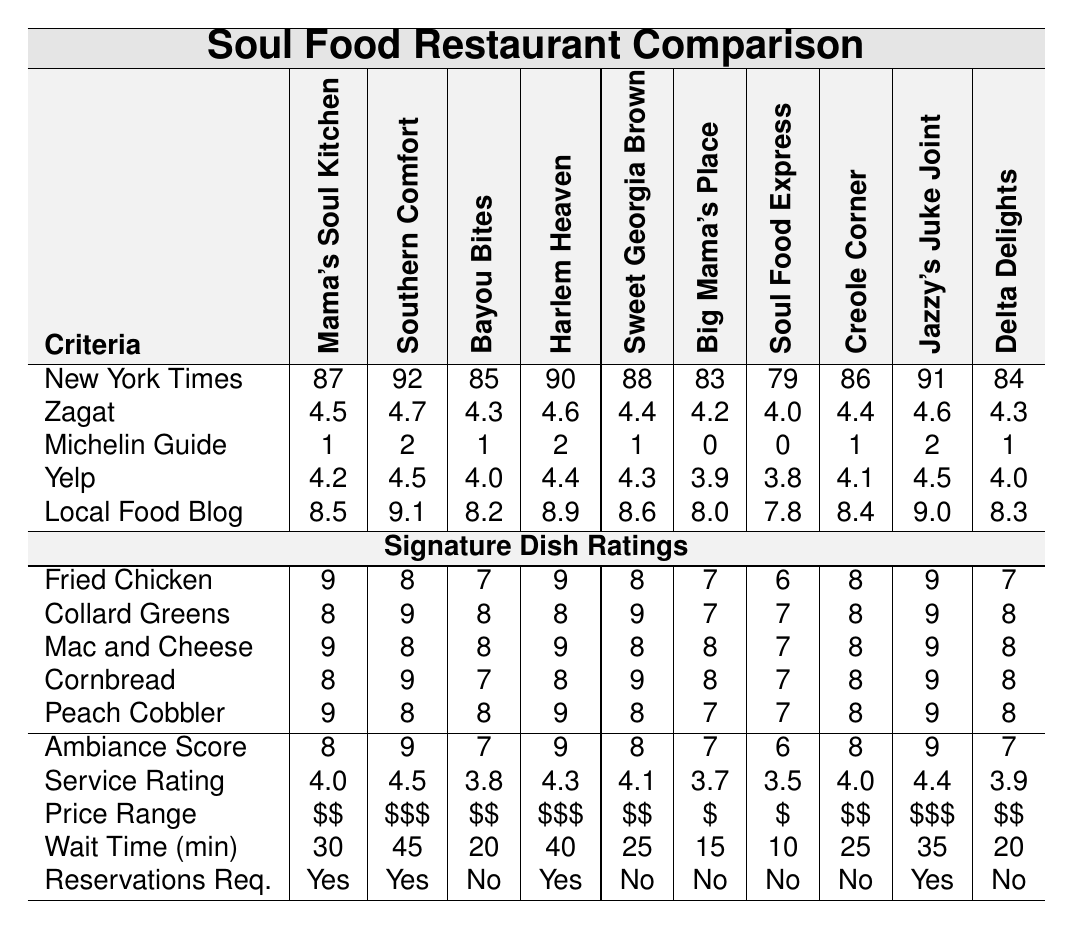What is the highest score given to Mama's Soul Kitchen by the New York Times? According to the table, Mama's Soul Kitchen received a score of 87 from the New York Times.
Answer: 87 Which restaurant has the highest service rating? By checking the service ratings for each restaurant, Southern Comfort has the highest service rating of 4.5.
Answer: Southern Comfort What is the average ambiance score across all restaurants? To find the average ambiance score, sum up all ambiance scores (8 + 9 + 7 + 9 + 8 + 7 + 6 + 8 + 9 + 7 = 78) and divide by the number of restaurants (10). Thus, the average is 78/10 = 7.8.
Answer: 7.8 Did any restaurant receive a Michelin Guide rating of 0? Looking at the Michelin Guide ratings, Big Mama's Place and Soul Food Express both received a rating of 0. Therefore, yes, there are restaurants with a Michelin rating of 0.
Answer: Yes Which restaurant has the lowest wait time, and how long is it? Examining the wait times, Soul Food Express has the lowest wait time of 10 minutes.
Answer: Soul Food Express, 10 minutes How many restaurants have a Zagat score lower than 4.3? Checking the Zagat scores reveals that two restaurants—Big Mama's Place (4.2) and Soul Food Express (4.0)—have scores lower than 4.3. Therefore, the answer is 2.
Answer: 2 What is the price range of the restaurant with the highest Local Food Blog rating? Looking at the highest rating (9.1) from the Local Food Blog, it corresponds to Southern Comfort. Its price range is $$$.
Answer: $$$ Which signature dish received the highest average rating across all restaurants, and what is that average? Checking the ratings for each signature dish: Fried Chicken (8.2), Collard Greens (8.4), Mac and Cheese (8.0), Cornbread (8.3), and Peach Cobbler (8.2). The dish with the highest average rating is Collard Greens with an average of 8.4.
Answer: Collard Greens, 8.4 Is there any restaurant that requires reservations but also has the lowest food critic score from the New York Times? Analyzing the table, Soul Food Express has the lowest NY Times score (79) and does not require reservations, so the answer is no, there isn't such a restaurant.
Answer: No Which restaurant has both a high Yelp rating and a high ambiance score? After checking both the Yelp ratings and ambiance scores, Mama's Soul Kitchen (4.2 Yelp, 8 ambiance) and Harlem Heaven (4.4 Yelp, 9 ambiance) meet the criteria; therefore, two restaurants do.
Answer: Mama's Soul Kitchen and Harlem Heaven 